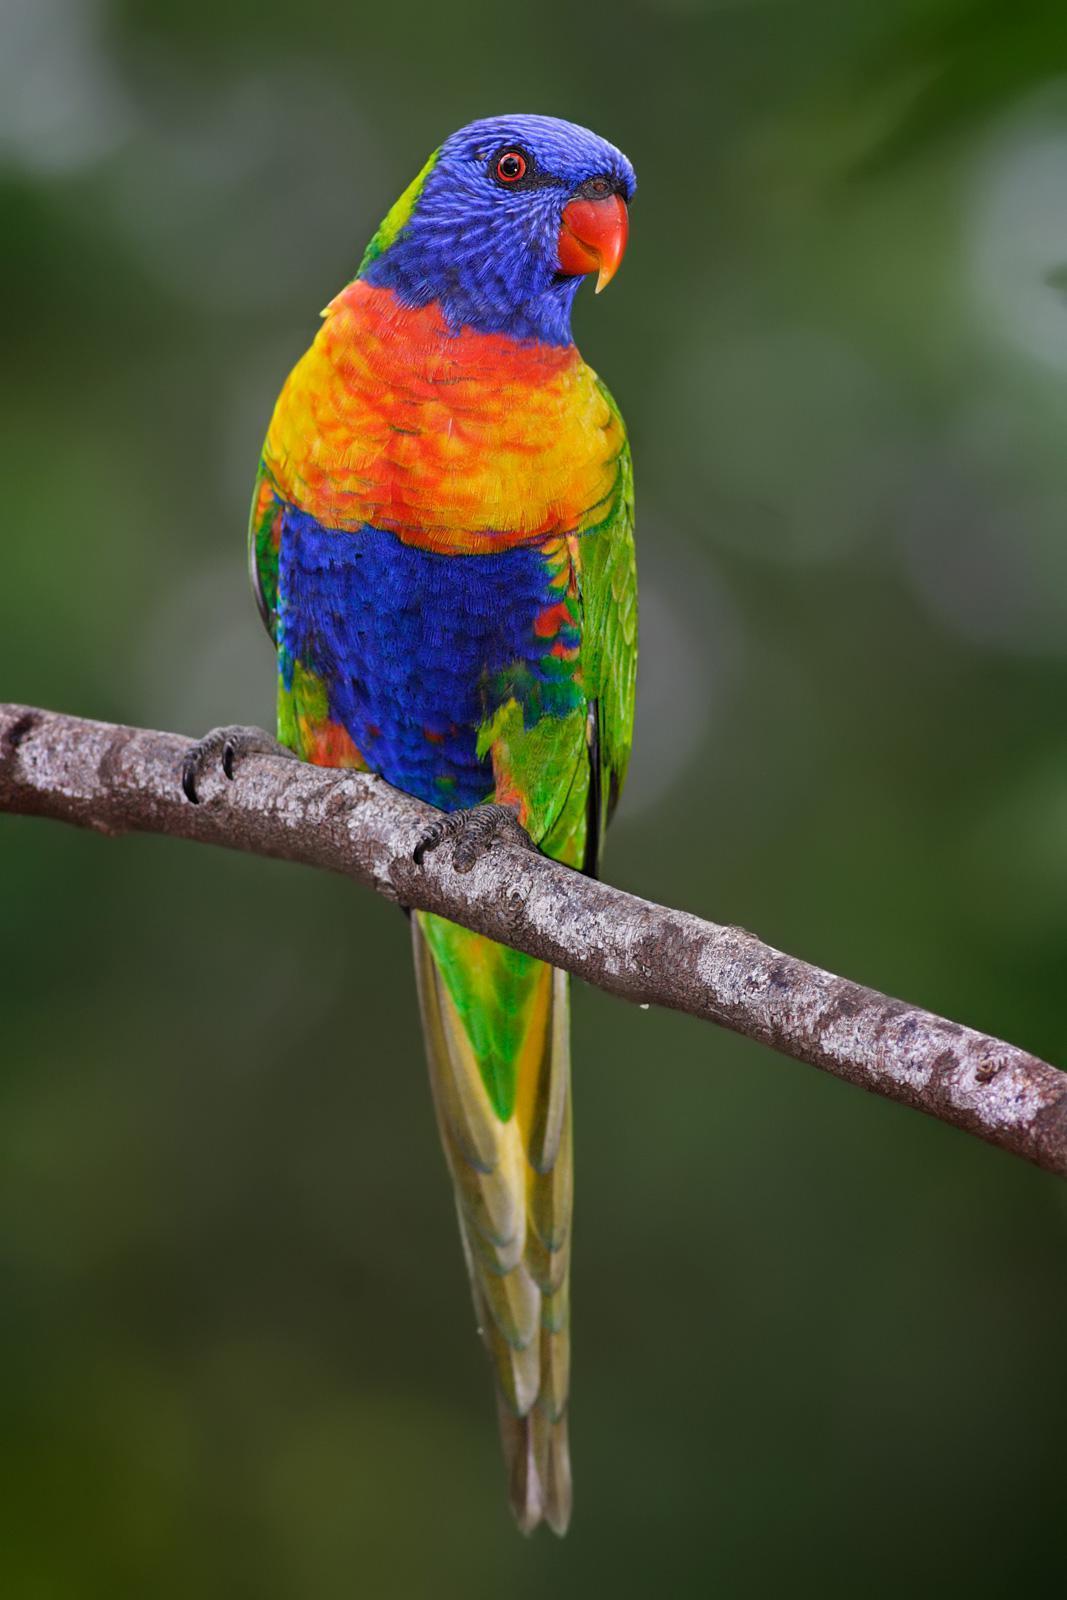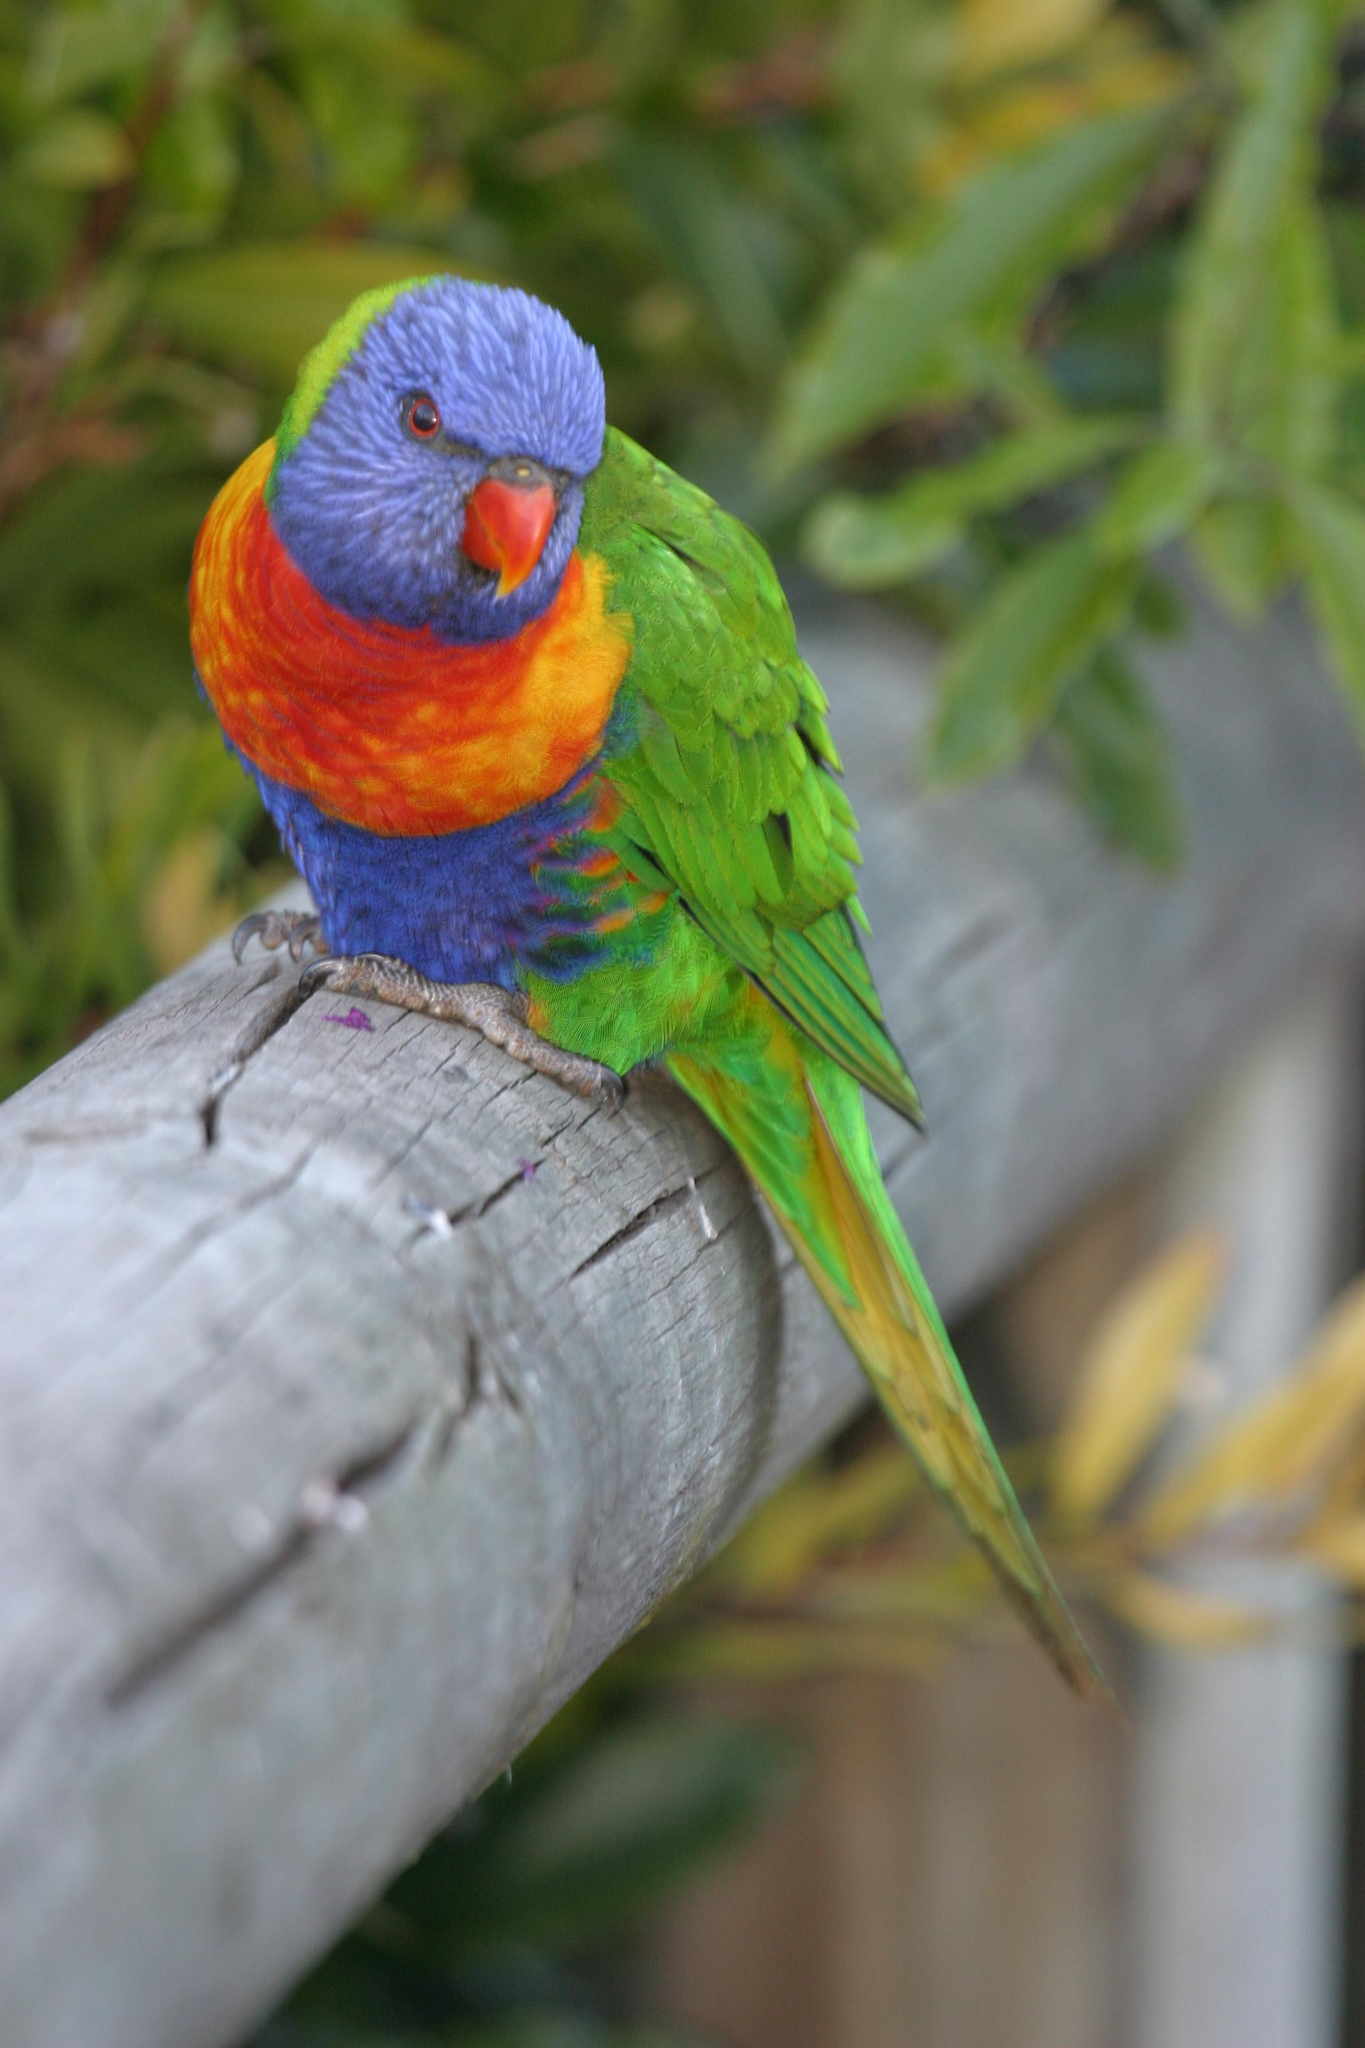The first image is the image on the left, the second image is the image on the right. Given the left and right images, does the statement "All of the birds are perched with their breast turned toward the camera." hold true? Answer yes or no. Yes. 